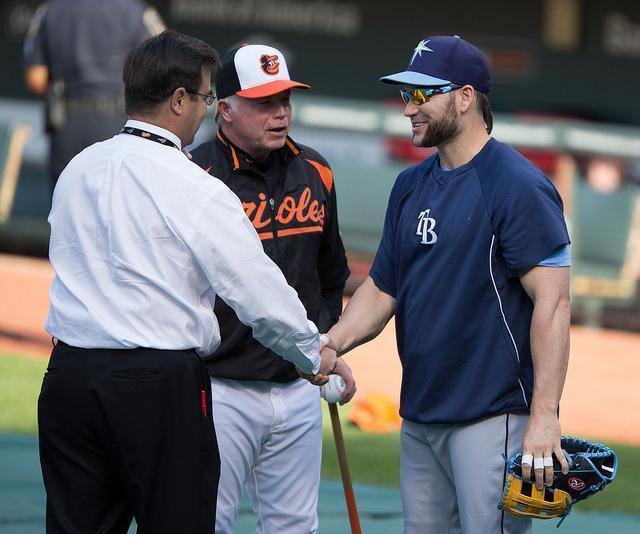How many people are in the picture?
Give a very brief answer. 4. 